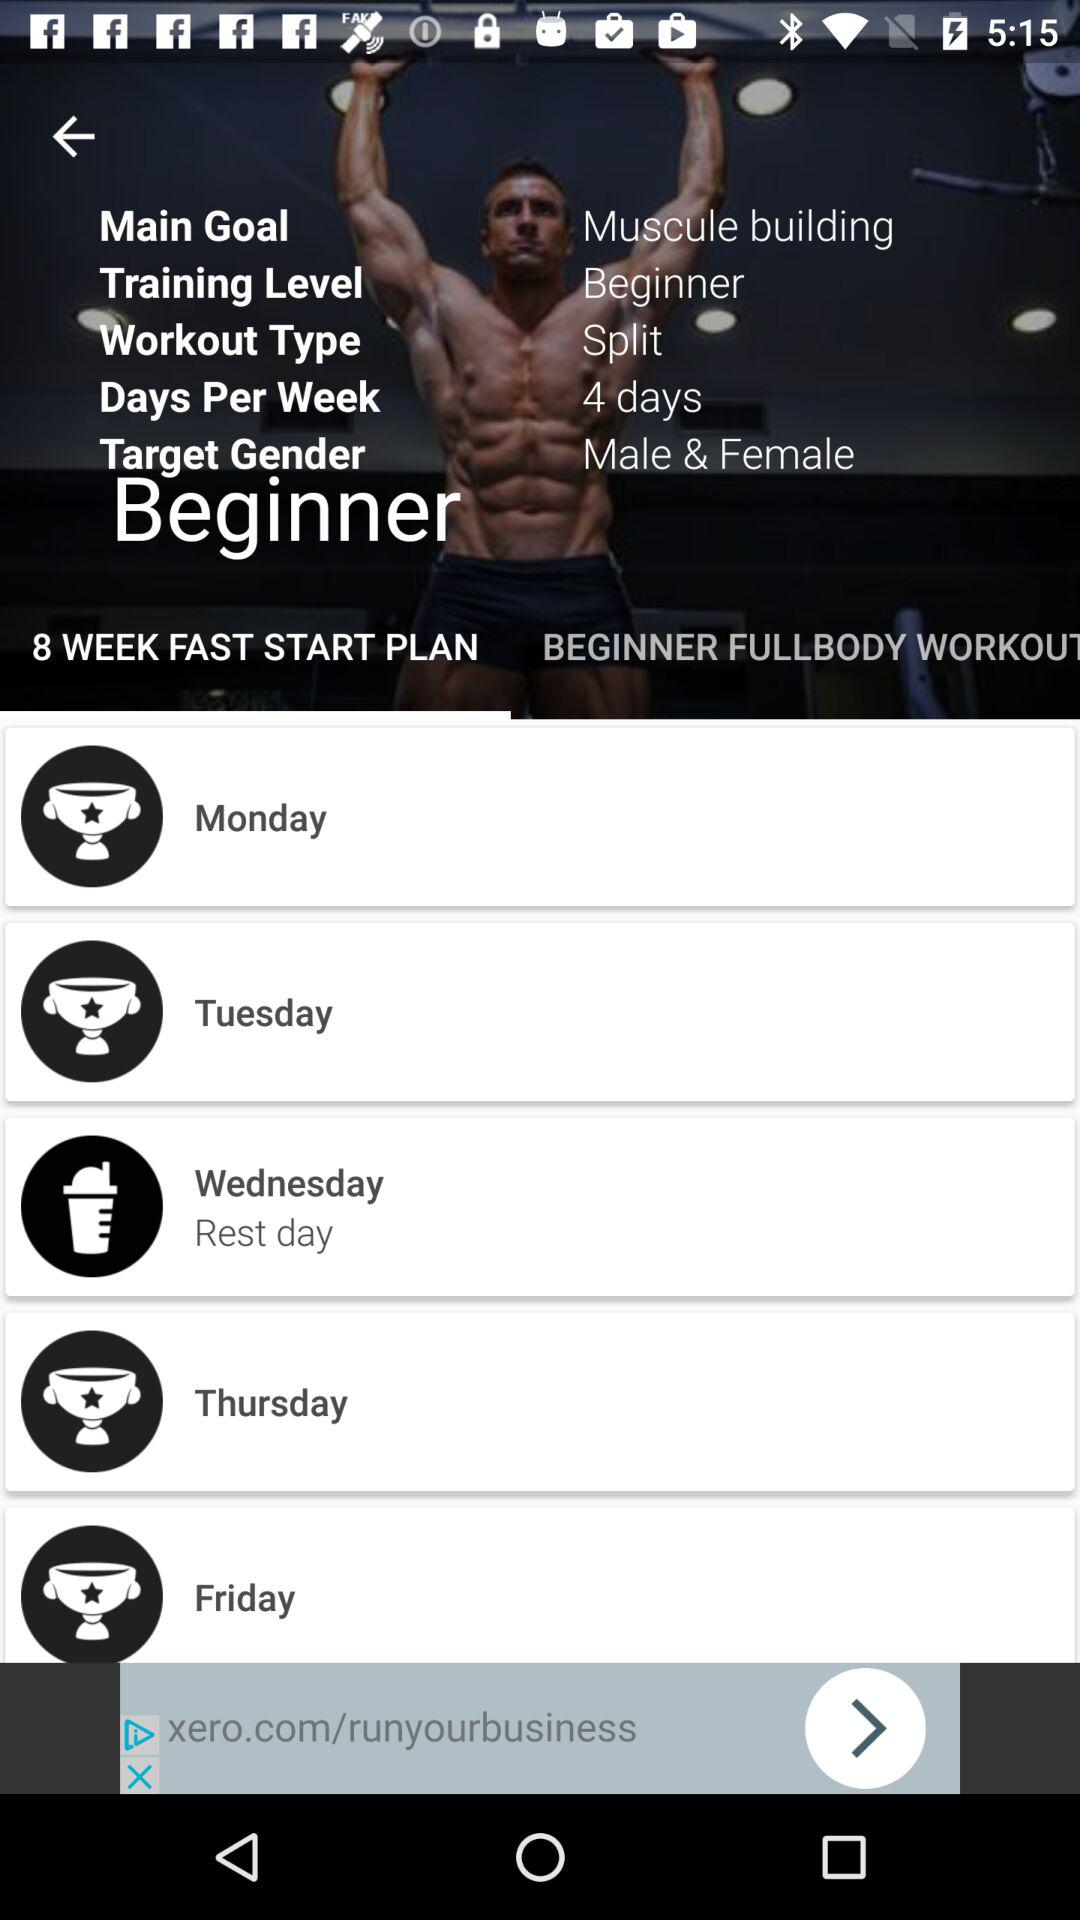Which day is set as the rest day? The day that is set as the rest day is Wednesday. 